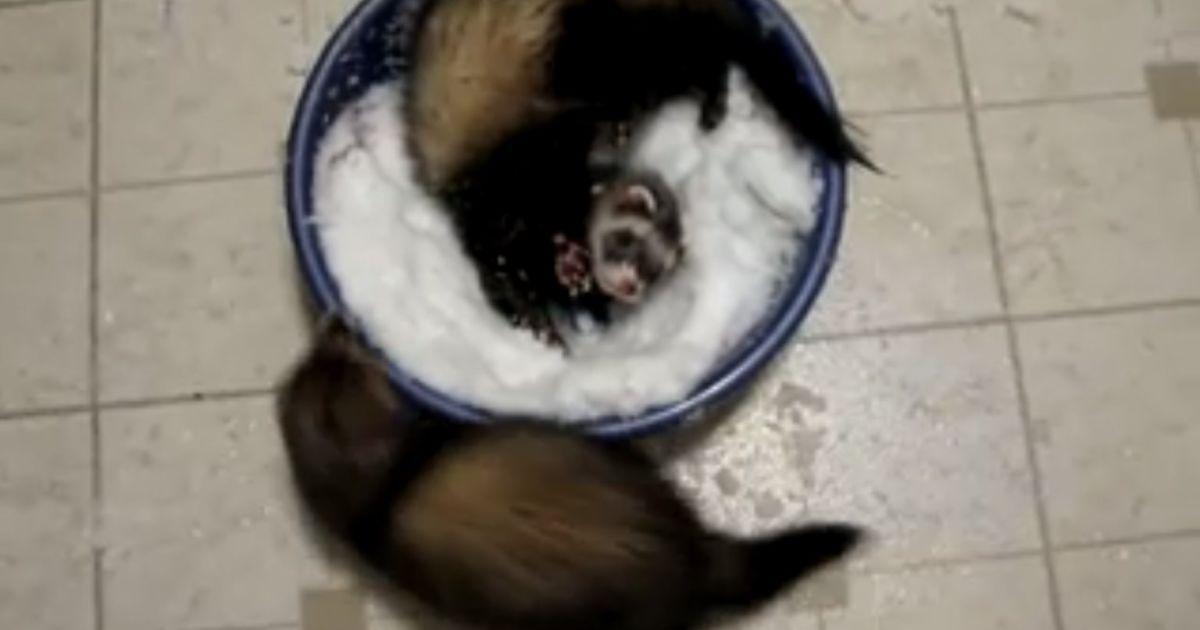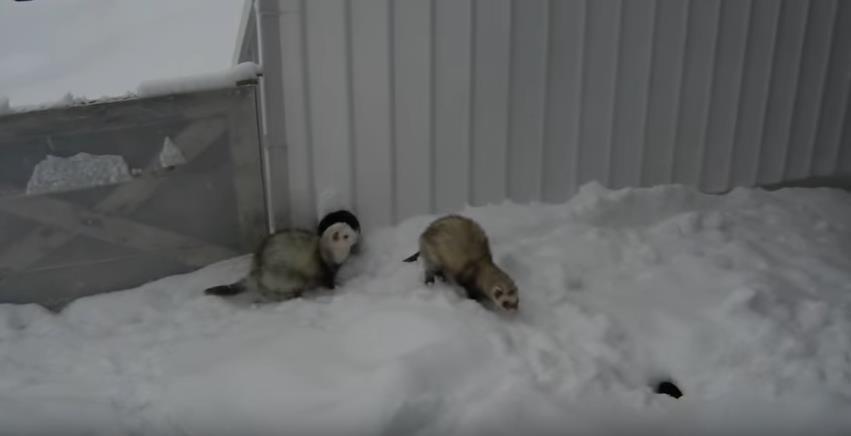The first image is the image on the left, the second image is the image on the right. For the images displayed, is the sentence "An image shows a ferret in a bowl of white fluff." factually correct? Answer yes or no. Yes. 